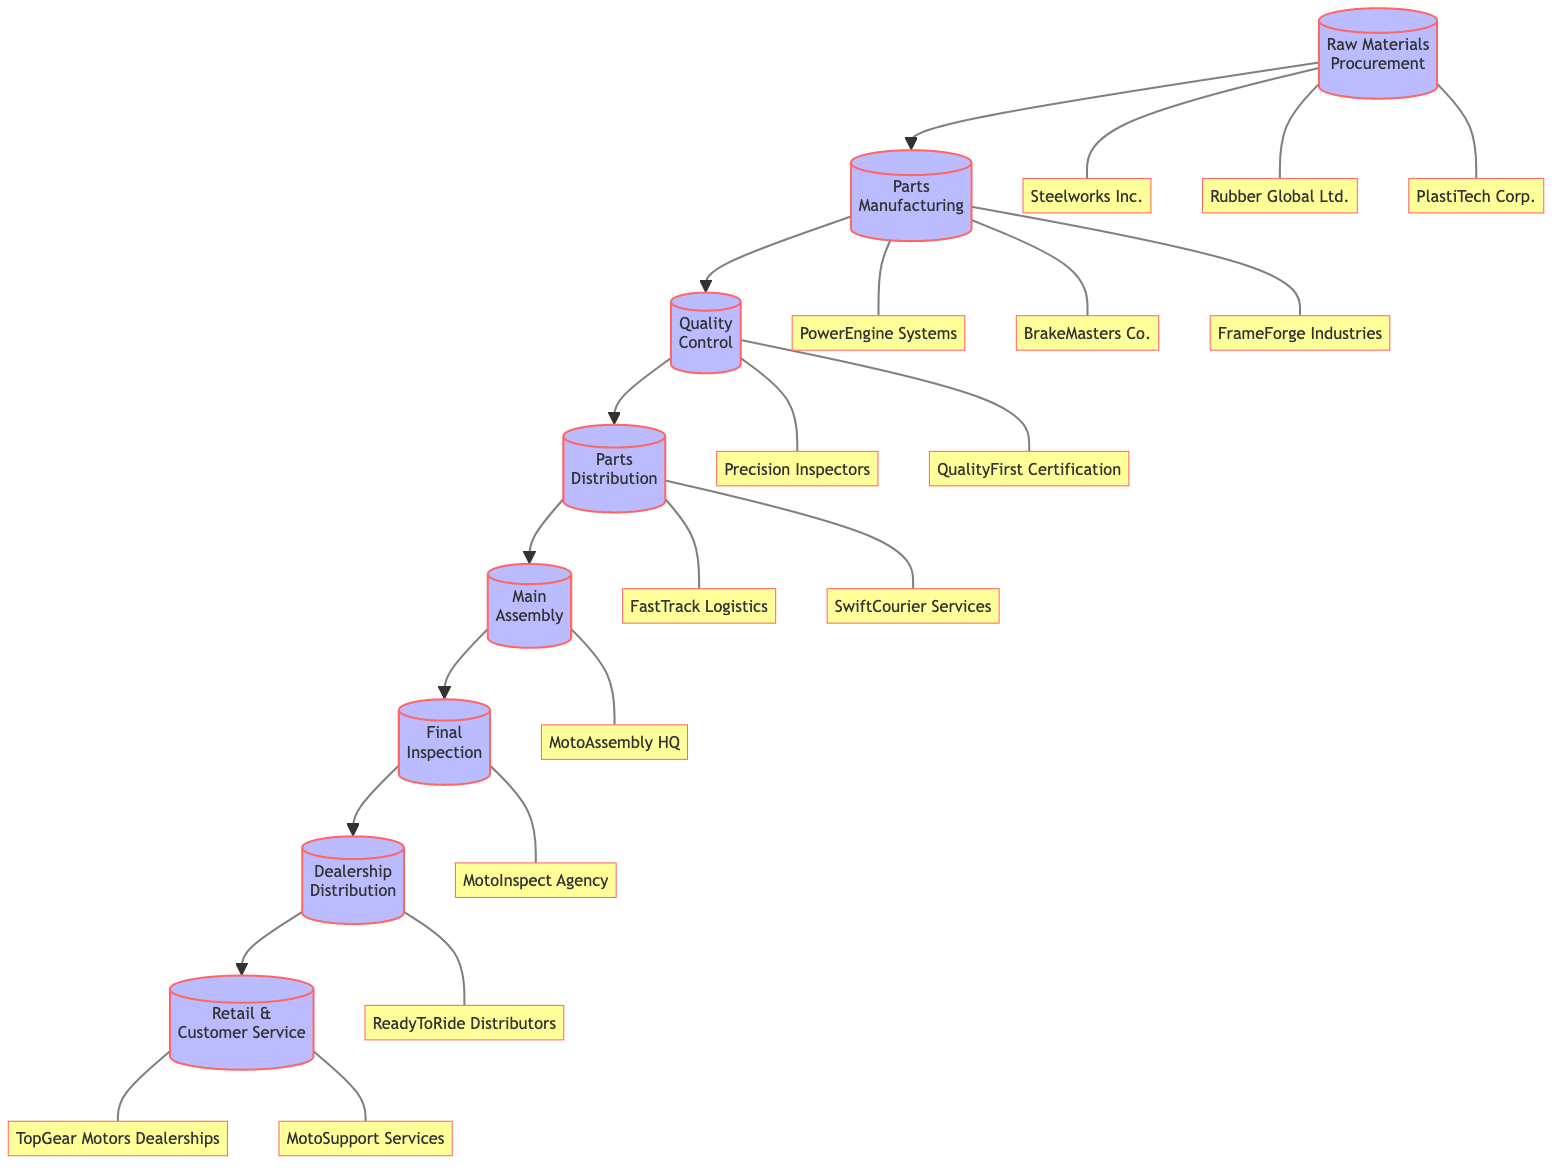What is the first step in the supply chain? The first step in the supply chain is Raw Materials Procurement, which involves sourcing raw materials from various suppliers.
Answer: Raw Materials Procurement How many entities are involved in Parts Manufacturing? Parts Manufacturing has three entities listed: PowerEngine Systems, BrakeMasters Co., and FrameForge Industries.
Answer: 3 What is the last step before Retail & Customer Service? The last step before Retail & Customer Service is Dealership Distribution, which focuses on delivering assembled motorcycles to dealerships.
Answer: Dealership Distribution Which entity is responsible for Quality Control? The entities responsible for Quality Control are Precision Inspectors and QualityFirst Certification, ensuring that all parts meet standards.
Answer: Precision Inspectors, QualityFirst Certification What connects Parts Distribution to Main Assembly? Parts Distribution connects to Main Assembly, indicating that parts are transported to the assembly plants where motorcycles are assembled.
Answer: Parts Distribution In total, how many steps are in the supply chain? The supply chain consists of eight steps, from Raw Materials Procurement to Retail & Customer Service, providing a complete flow from materials to customer service.
Answer: 8 Which step involves comprehensive testing of finished motorcycles? The step that involves comprehensive testing of finished motorcycles is Final Inspection, which ensures performance and safety before delivery.
Answer: Final Inspection What is the purpose of the Quality Control step? The purpose of the Quality Control step is to ensure each part meets quality and safety standards before proceeding to assembly.
Answer: Ensuring quality and safety standards What type of services are provided by MotoSupport Services? MotoSupport Services provides after-sales support for customers at the dealerships, assisting with any motorcycle-related inquiries or issues.
Answer: After-sales support 